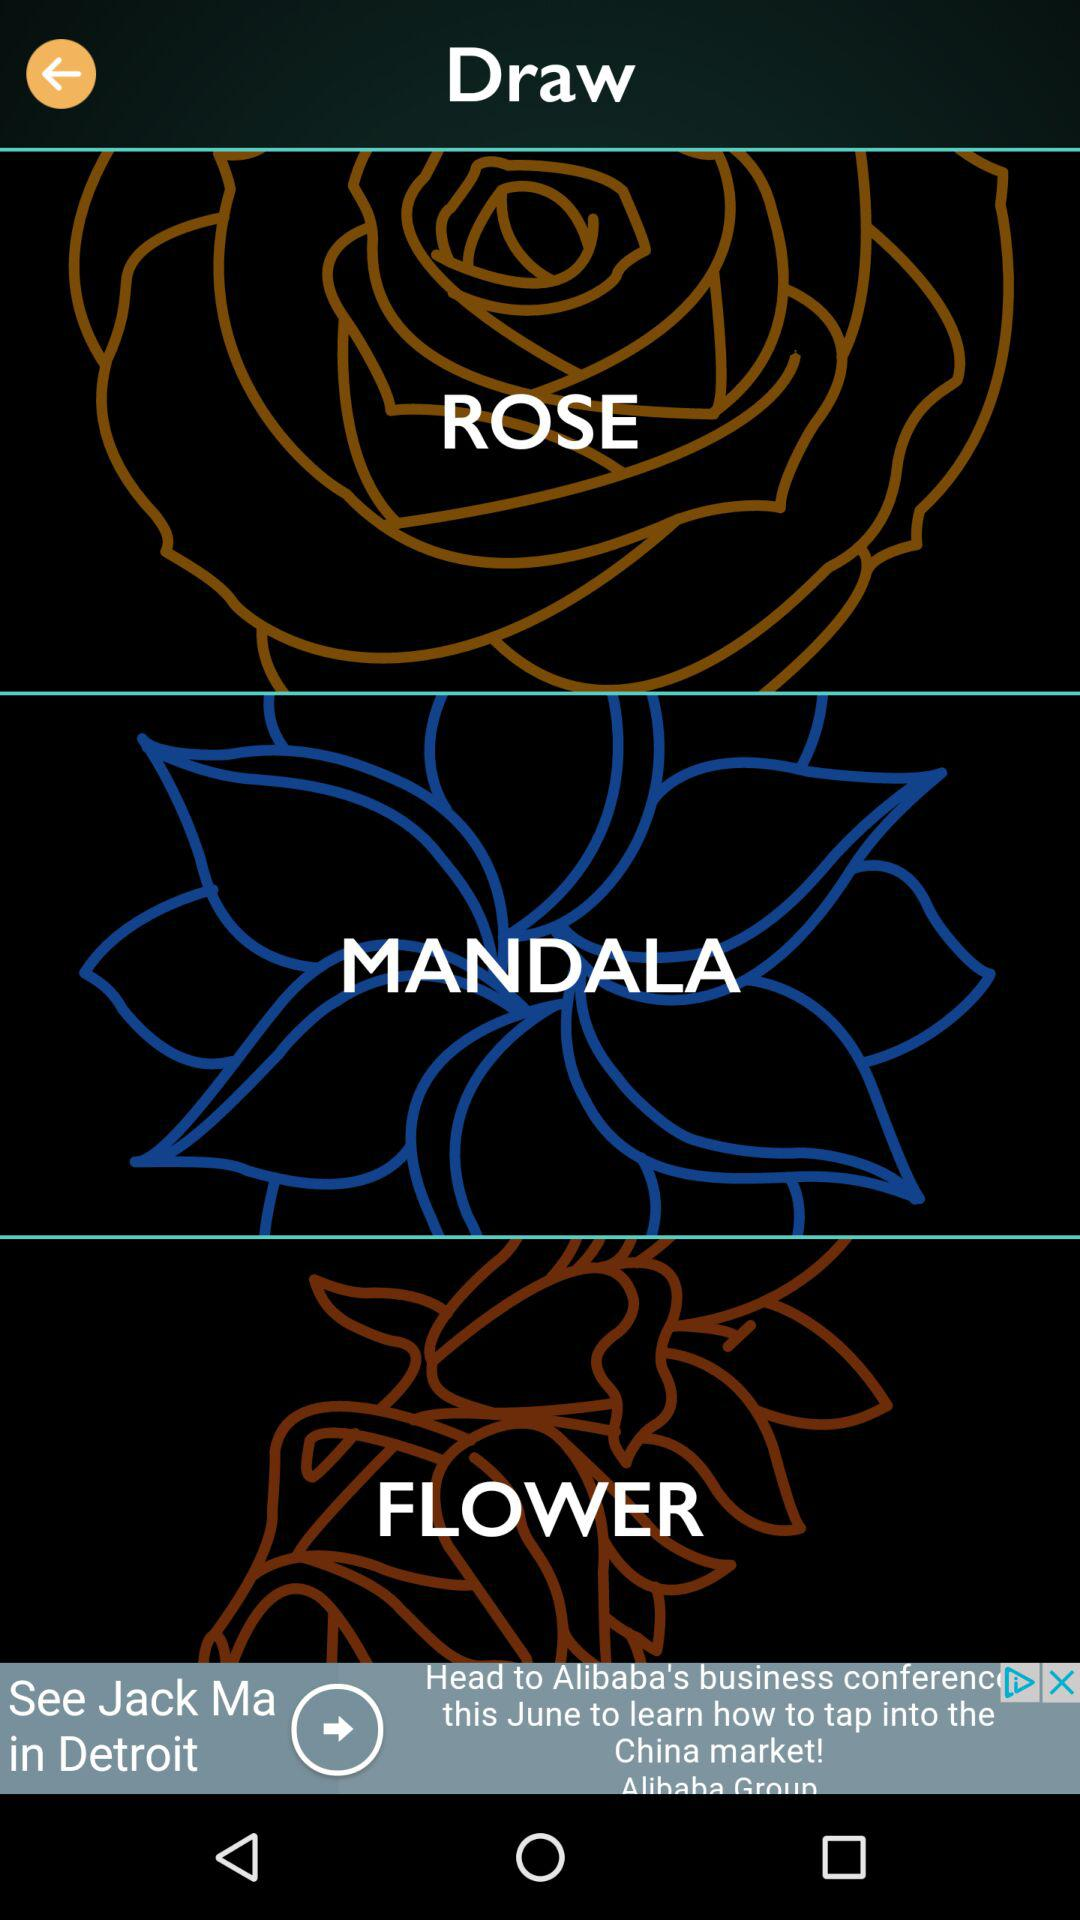How many items have a black background?
Answer the question using a single word or phrase. 3 